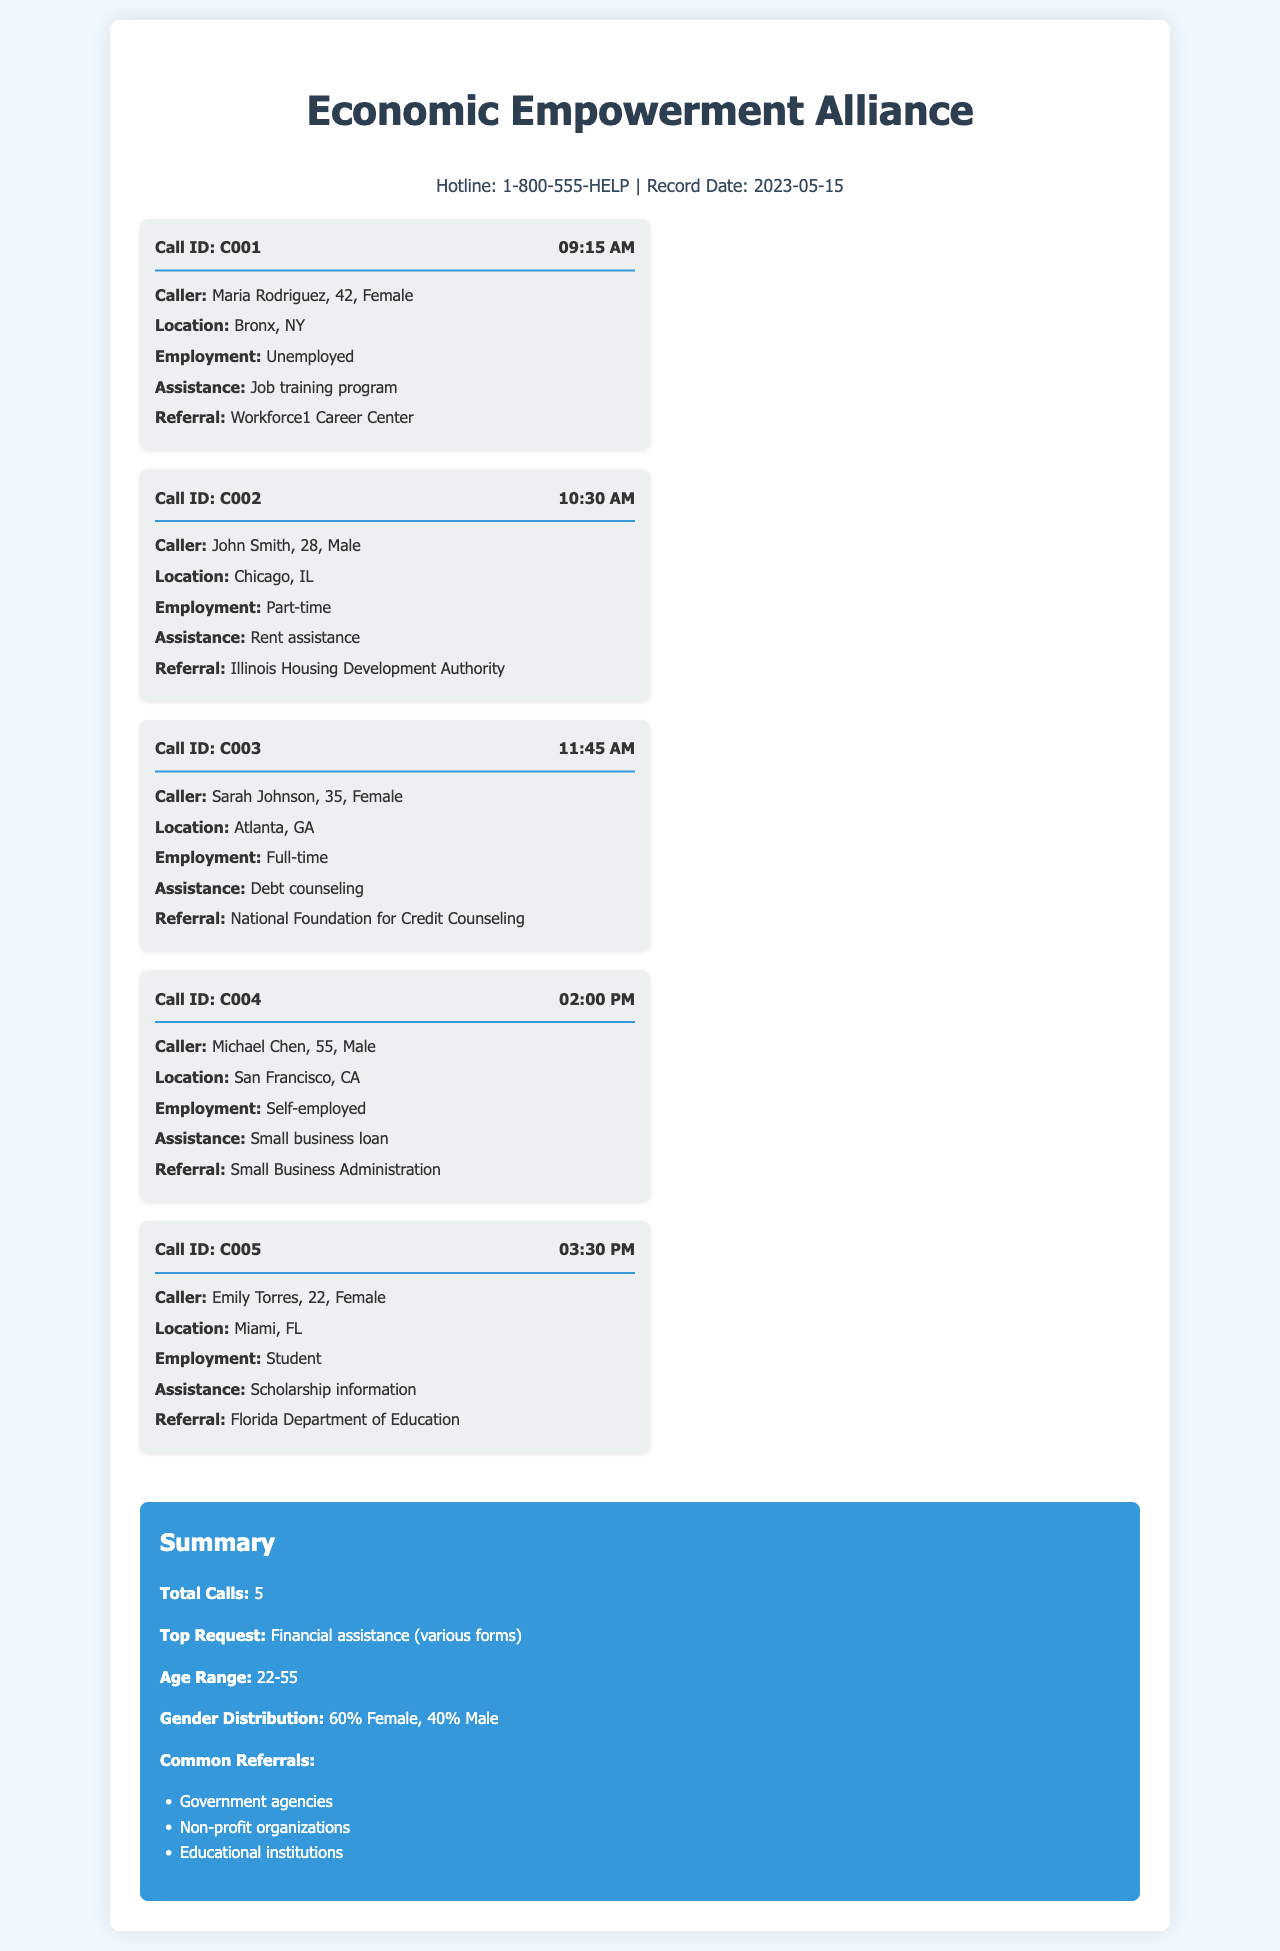What is the hotline number? The hotline number is provided at the start of the document for individuals seeking assistance.
Answer: 1-800-555-HELP How many total calls were recorded? The total number of calls is summarized at the end of the document.
Answer: 5 What type of assistance did Maria Rodriguez request? The document includes details on the specific assistance requested by each caller.
Answer: Job training program What age range do the callers fall into? The age range of callers is mentioned in the summary section of the document.
Answer: 22-55 Who was referred to the Florida Department of Education? Each call record lists the referrals made for assistance, noting specific callers.
Answer: Emily Torres How many males called the hotline? The gender distribution is summarized, allowing for calculation based on provided percentages and total calls.
Answer: 2 What was the time of John Smith's call? The document lists the time for each call, indicating when the caller reached out for help.
Answer: 10:30 AM What common referrals are mentioned in the records? The summary section highlights the types of organizations to which callers were referred.
Answer: Government agencies What is the gender distribution percentage of Female callers? The gender distribution is provided in the summary, reflecting the percentage of female callers.
Answer: 60% Female 